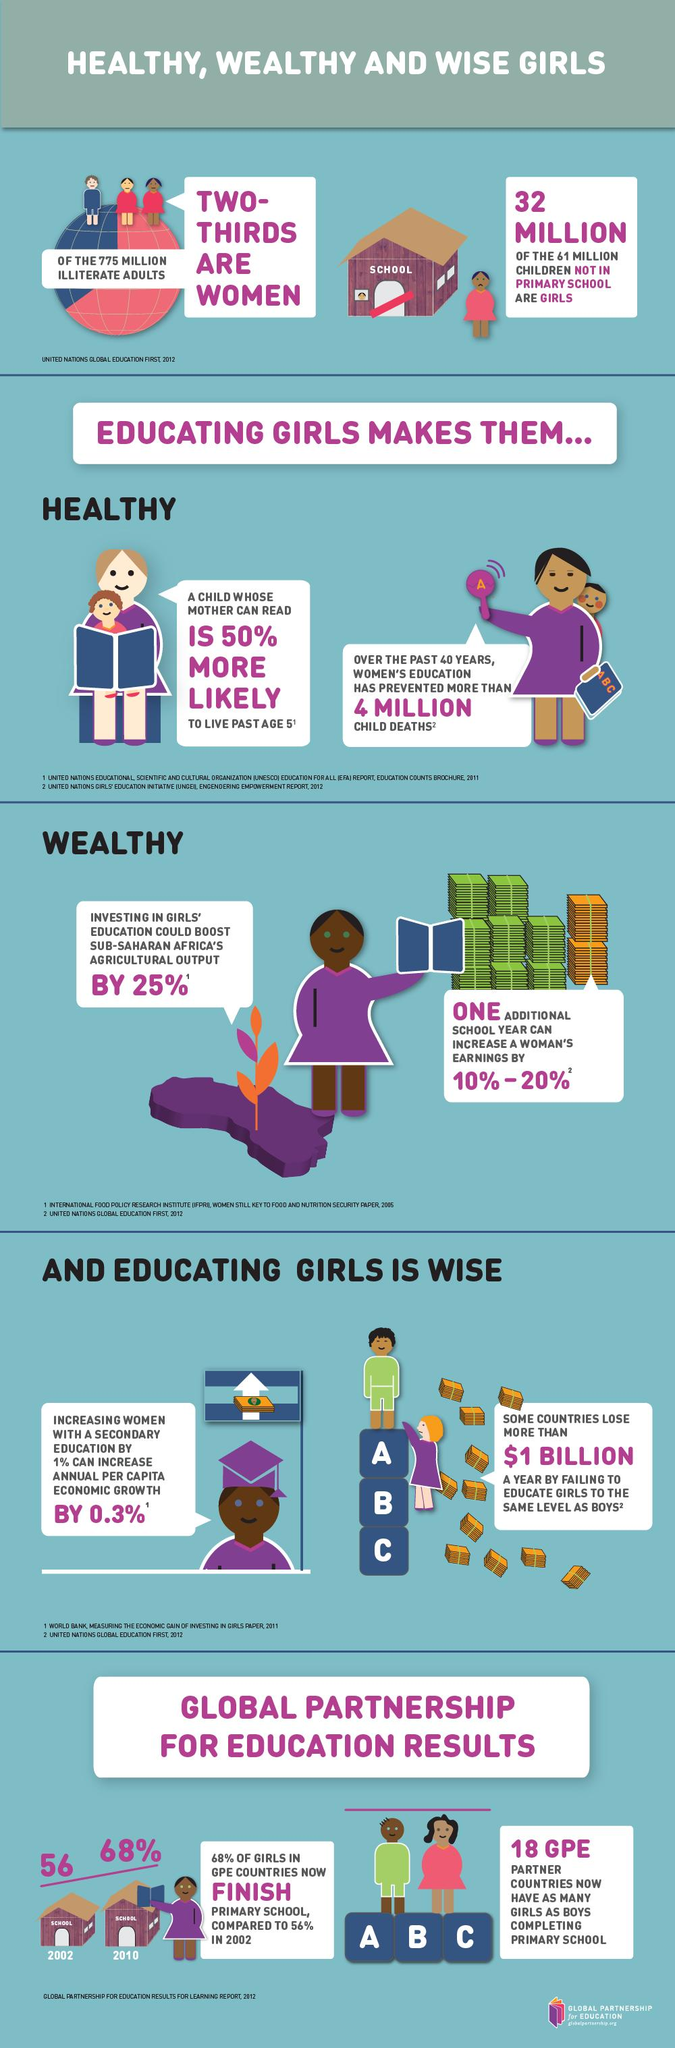Mention a couple of crucial points in this snapshot. Approximately 29 million boys do not attend primary school, which accounts for roughly 26% of global out-of-school children. Educating girls makes them healthy, wealthy, and wise. In 2010, the percentage growth of girls finishing primary school compared to 2002 was 12%. 